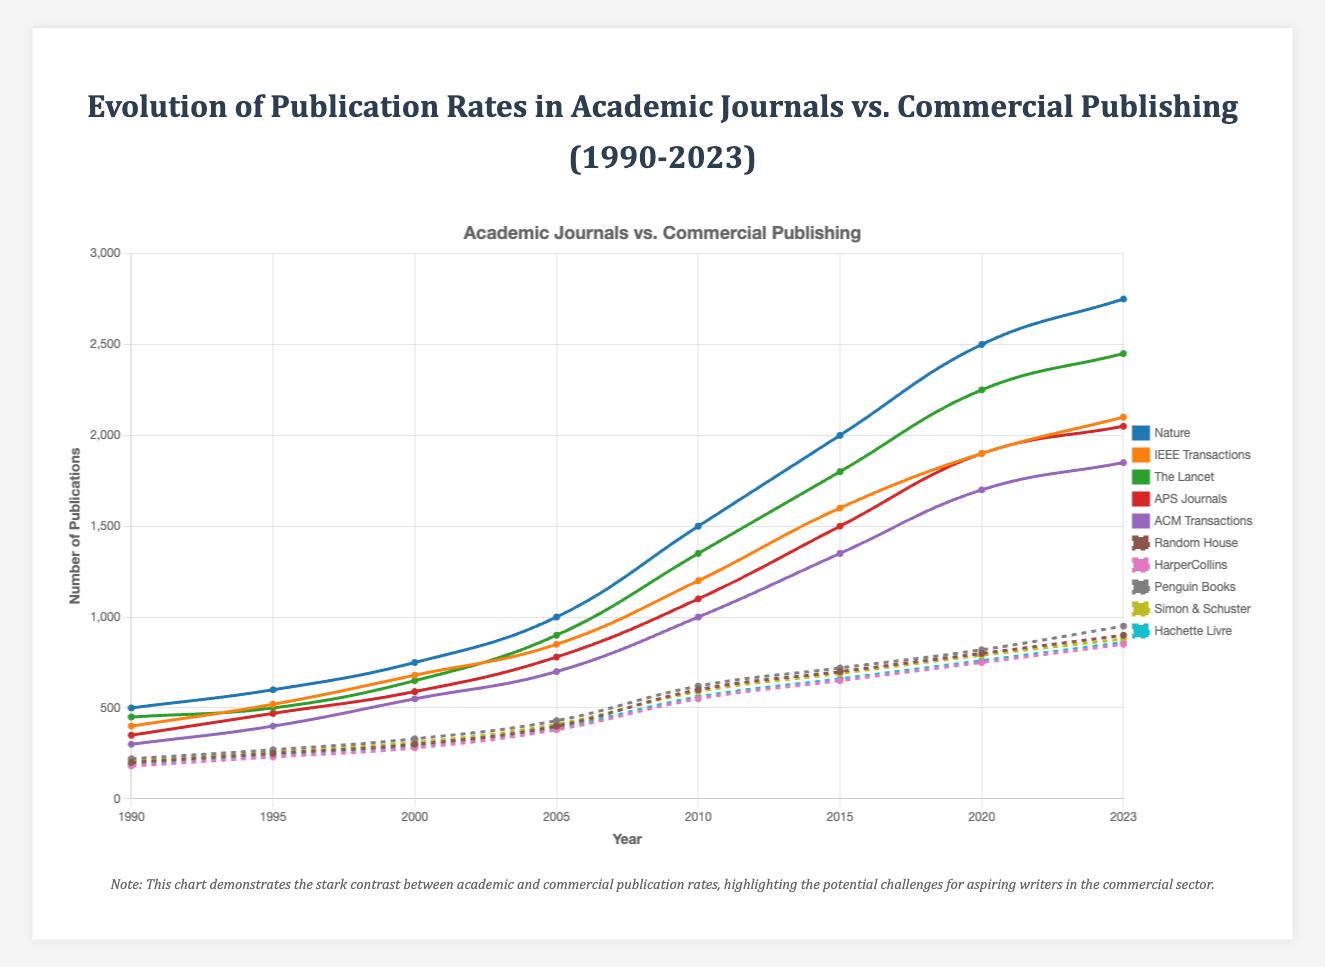Which academic journal had the highest number of publications in 2023? In 2023, the data for the number of publications shows "Nature" with 2750, which is higher than all other academic journals listed.
Answer: Nature Compare the publication rates of "IEEE Transactions" and "Random House" in 2010. Which one had a higher number of publications? In 2010, "IEEE Transactions" had 1200 publications while "Random House" had 600 publications. Therefore, "IEEE Transactions" had a higher number of publications.
Answer: IEEE Transactions What is the average number of publications for "The Lancet" between 1990 and 2023? There are 8 data points for "The Lancet": (450, 500, 650, 900, 1350, 1800, 2250, 2450). Summing these gives 11350, and dividing by 8 gives an average of 1418.75 publications.
Answer: 1418.75 Which commercial publisher had the lowest number of publications in 2000? In 2000, comparing the numbers: Random House (300), HarperCollins (280), Penguin Books (330), Simon & Schuster (310), Hachette Livre (290), HarperCollins had the lowest number with 280 publications.
Answer: HarperCollins What is the difference in publication rates between "Nature" and "IEEE Transactions" in 2020? In 2020, "Nature" had 2500 publications and "IEEE Transactions" had 1900 publications. The difference is 2500 - 1900 = 600.
Answer: 600 By how much did the publication rate of "ACM Transactions" increase from 2010 to 2023? In 2010, "ACM Transactions" had 1000 publications, and in 2023, it had 1850 publications. The increase is 1850 - 1000 = 850.
Answer: 850 Which year shows the first instance of "Penguin Books" having more than 500 publications? In the dataset for "Penguin Books" the first instance where it exceeds 500 publications is in 2010, with 620 publications.
Answer: 2010 How many publications did "Simon & Schuster" have in total from 1990 to 2023? Summing up the publications for "Simon & Schuster": (210, 260, 310, 410, 590, 690, 790, 880) equals 4140.
Answer: 4140 Compare the slope of the publication rates of "Nature" and "Random House" between 1990 and 2023. Which one grew faster? The publication rate for "Nature" increased by (2750 - 500 = 2250) over 33 years, while "Random House" increased by (900 - 200 = 700) over 33 years. "Nature" grew faster as its increase in publications is 2250 compared to 700 for "Random House".
Answer: Nature 